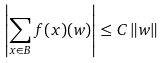<formula> <loc_0><loc_0><loc_500><loc_500>\left | \sum _ { x \in B } f ( x ) ( w ) \right | \leq C \, \| w \|</formula> 